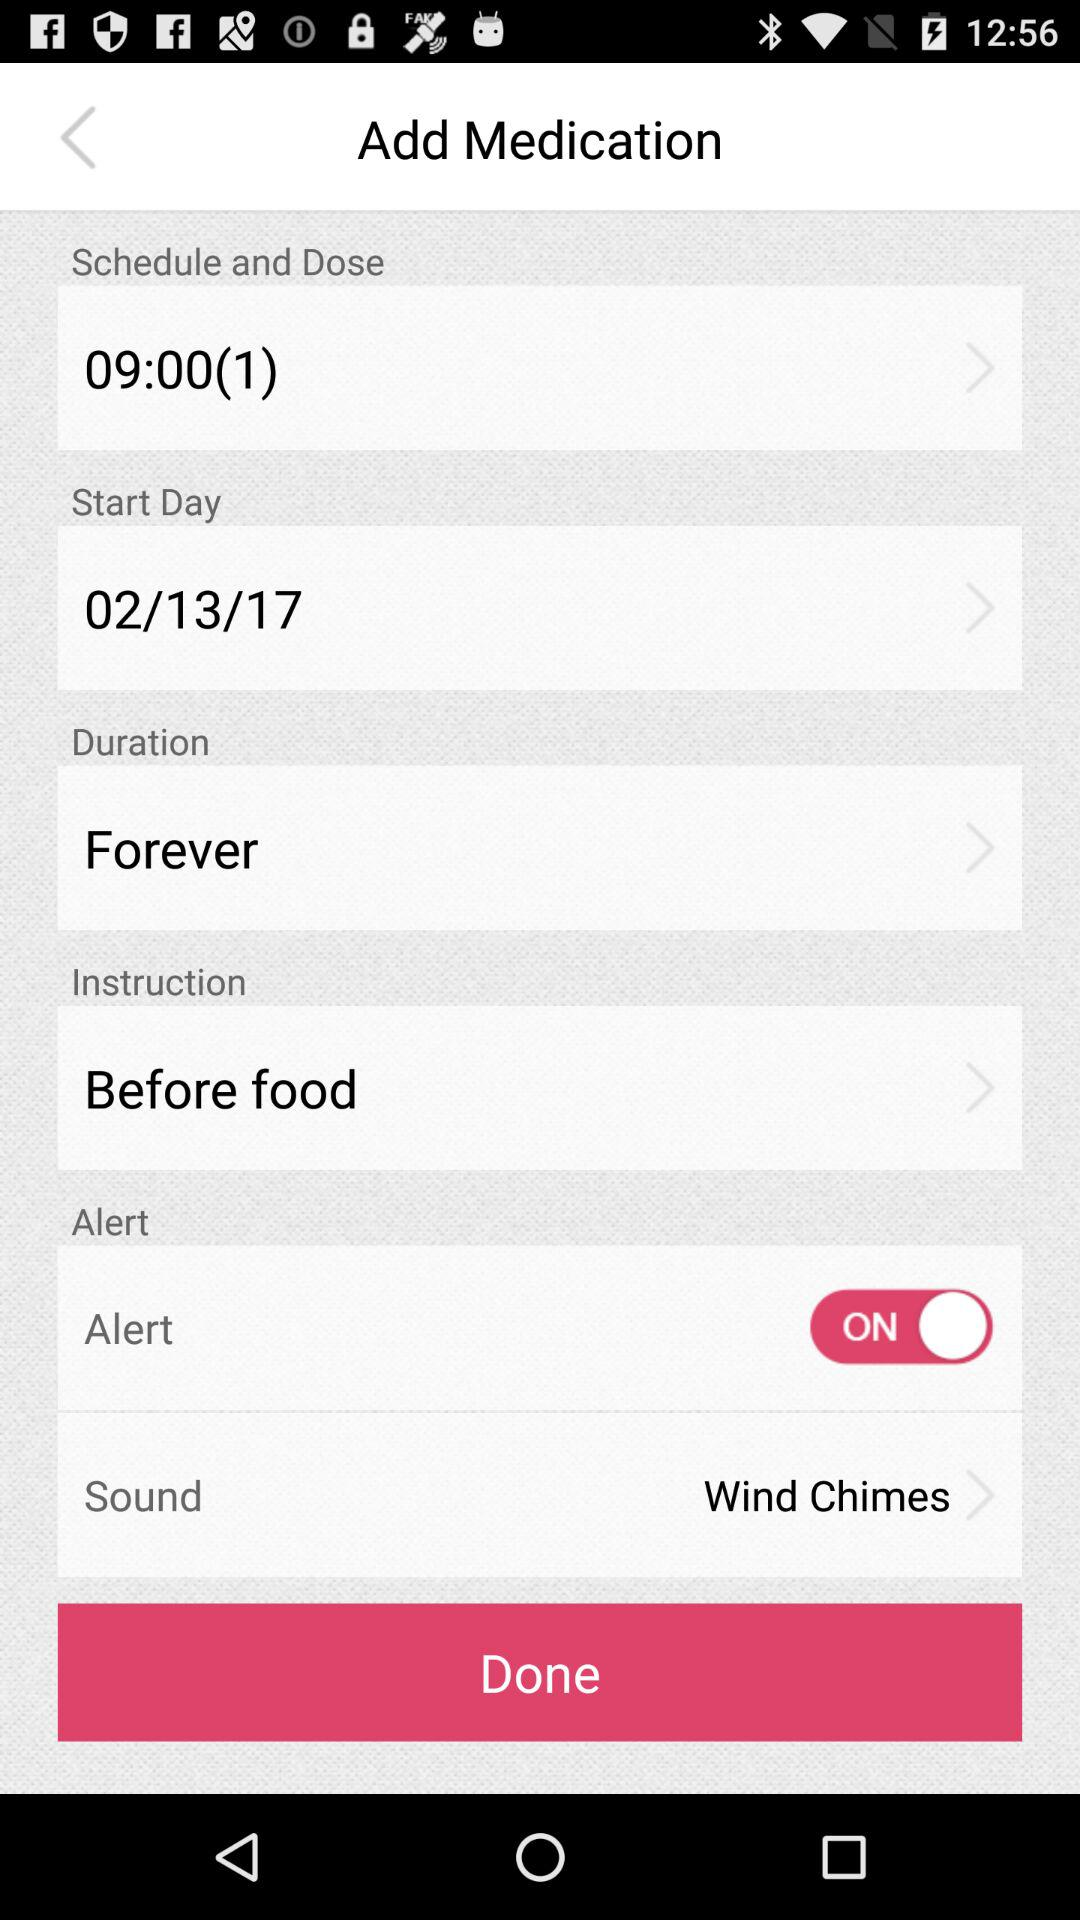What is the instruction? The instruction is "Before food". 